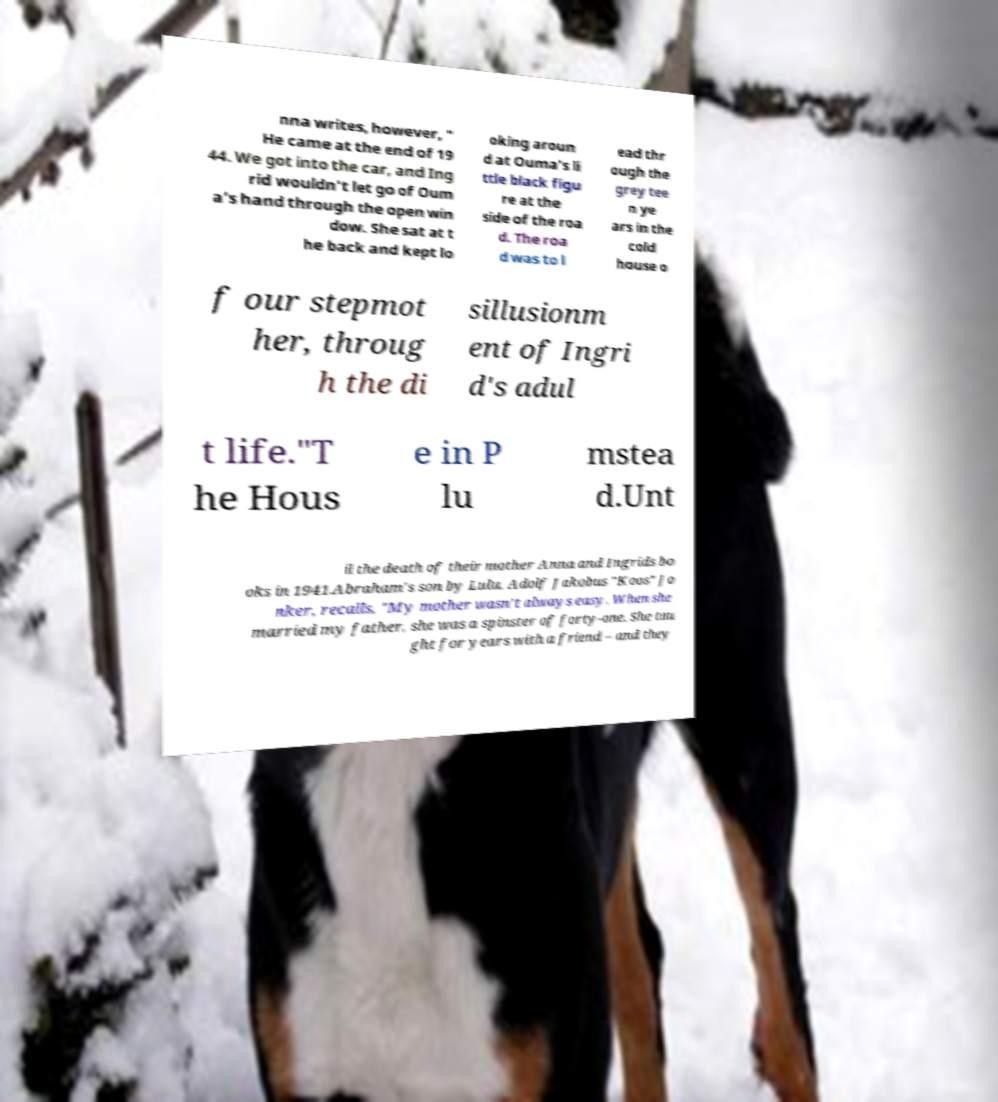Could you extract and type out the text from this image? nna writes, however, " He came at the end of 19 44. We got into the car, and Ing rid wouldn't let go of Oum a's hand through the open win dow. She sat at t he back and kept lo oking aroun d at Ouma's li ttle black figu re at the side of the roa d. The roa d was to l ead thr ough the grey tee n ye ars in the cold house o f our stepmot her, throug h the di sillusionm ent of Ingri d's adul t life."T he Hous e in P lu mstea d.Unt il the death of their mother Anna and Ingrids bo oks in 1941.Abraham's son by Lulu, Adolf Jakobus "Koos" Jo nker, recalls, "My mother wasn't always easy. When she married my father, she was a spinster of forty-one. She tau ght for years with a friend – and they 